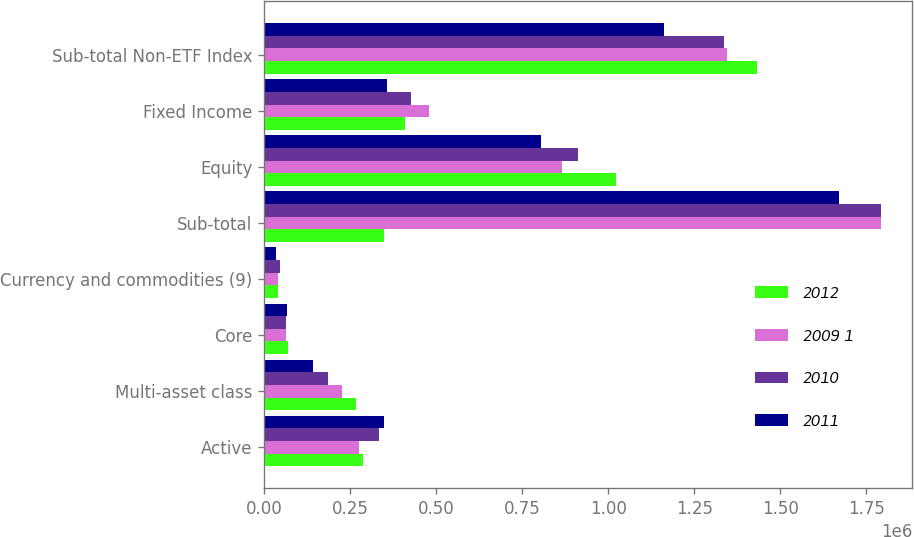Convert chart. <chart><loc_0><loc_0><loc_500><loc_500><stacked_bar_chart><ecel><fcel>Active<fcel>Multi-asset class<fcel>Core<fcel>Currency and commodities (9)<fcel>Sub-total<fcel>Equity<fcel>Fixed Income<fcel>Sub-total Non-ETF Index<nl><fcel>2012<fcel>287215<fcel>267748<fcel>68367<fcel>41428<fcel>348574<fcel>1.02364e+06<fcel>410139<fcel>1.43378e+06<nl><fcel>2009 1<fcel>275156<fcel>225170<fcel>63647<fcel>41301<fcel>1.79353e+06<fcel>865299<fcel>479116<fcel>1.34442e+06<nl><fcel>2010<fcel>334532<fcel>185587<fcel>63603<fcel>46135<fcel>1.79341e+06<fcel>911775<fcel>425930<fcel>1.3377e+06<nl><fcel>2011<fcel>348574<fcel>142029<fcel>66058<fcel>36043<fcel>1.67217e+06<fcel>806082<fcel>357557<fcel>1.16364e+06<nl></chart> 